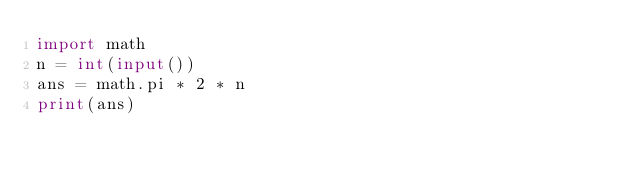Convert code to text. <code><loc_0><loc_0><loc_500><loc_500><_Python_>import math
n = int(input())
ans = math.pi * 2 * n
print(ans)
</code> 